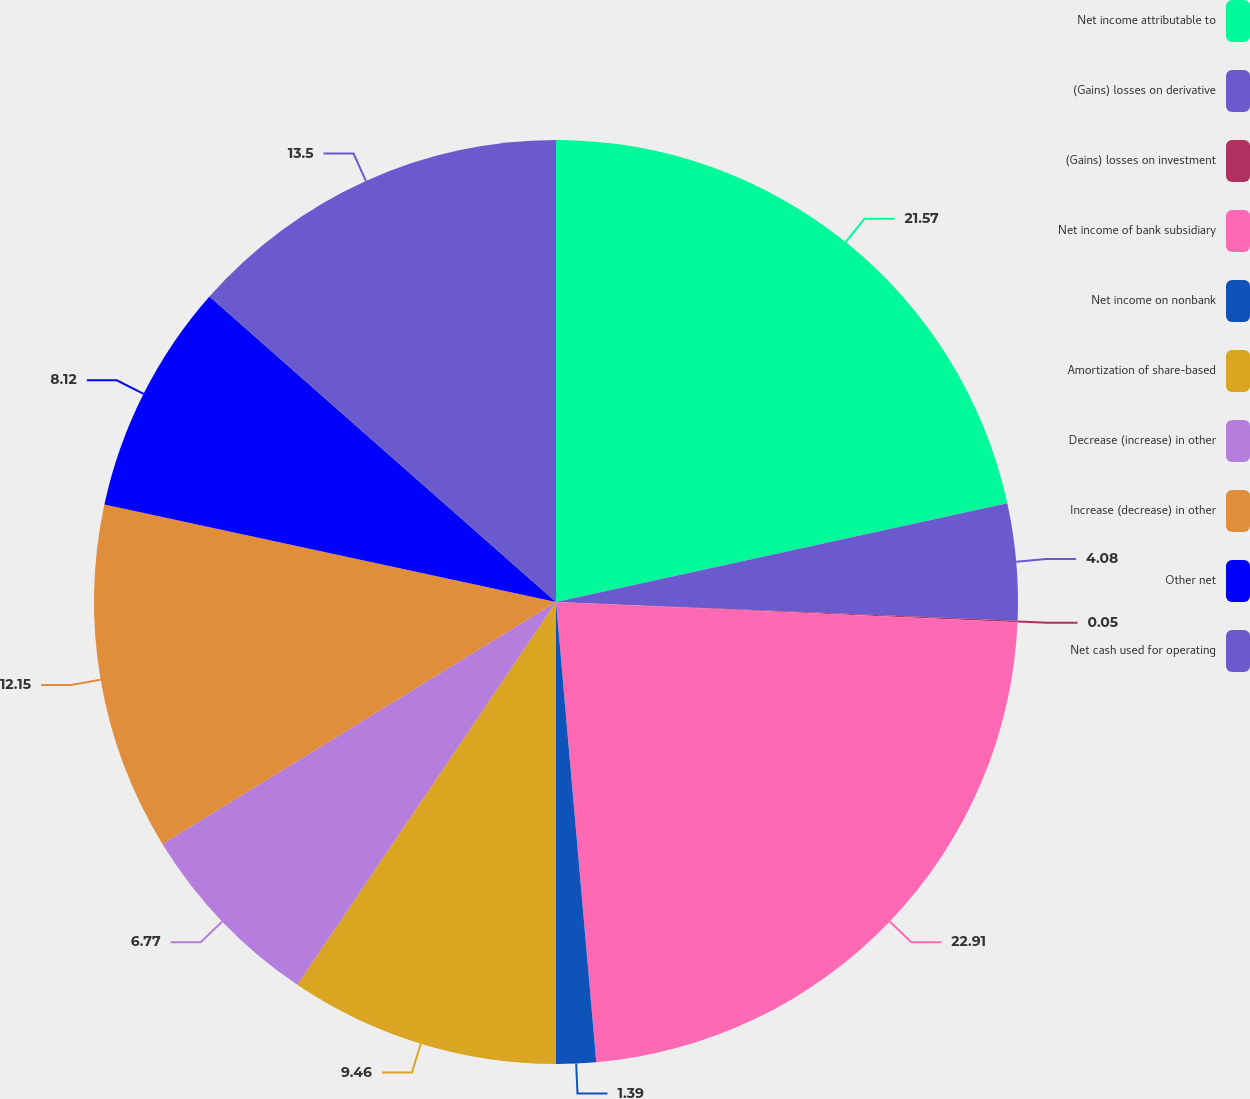Convert chart to OTSL. <chart><loc_0><loc_0><loc_500><loc_500><pie_chart><fcel>Net income attributable to<fcel>(Gains) losses on derivative<fcel>(Gains) losses on investment<fcel>Net income of bank subsidiary<fcel>Net income on nonbank<fcel>Amortization of share-based<fcel>Decrease (increase) in other<fcel>Increase (decrease) in other<fcel>Other net<fcel>Net cash used for operating<nl><fcel>21.57%<fcel>4.08%<fcel>0.05%<fcel>22.91%<fcel>1.39%<fcel>9.46%<fcel>6.77%<fcel>12.15%<fcel>8.12%<fcel>13.5%<nl></chart> 